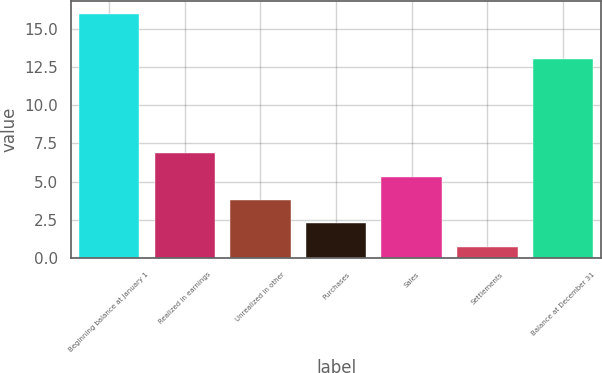Convert chart. <chart><loc_0><loc_0><loc_500><loc_500><bar_chart><fcel>Beginning balance at January 1<fcel>Realized in earnings<fcel>Unrealized in other<fcel>Purchases<fcel>Sales<fcel>Settlements<fcel>Balance at December 31<nl><fcel>16<fcel>6.85<fcel>3.79<fcel>2.26<fcel>5.32<fcel>0.73<fcel>13<nl></chart> 